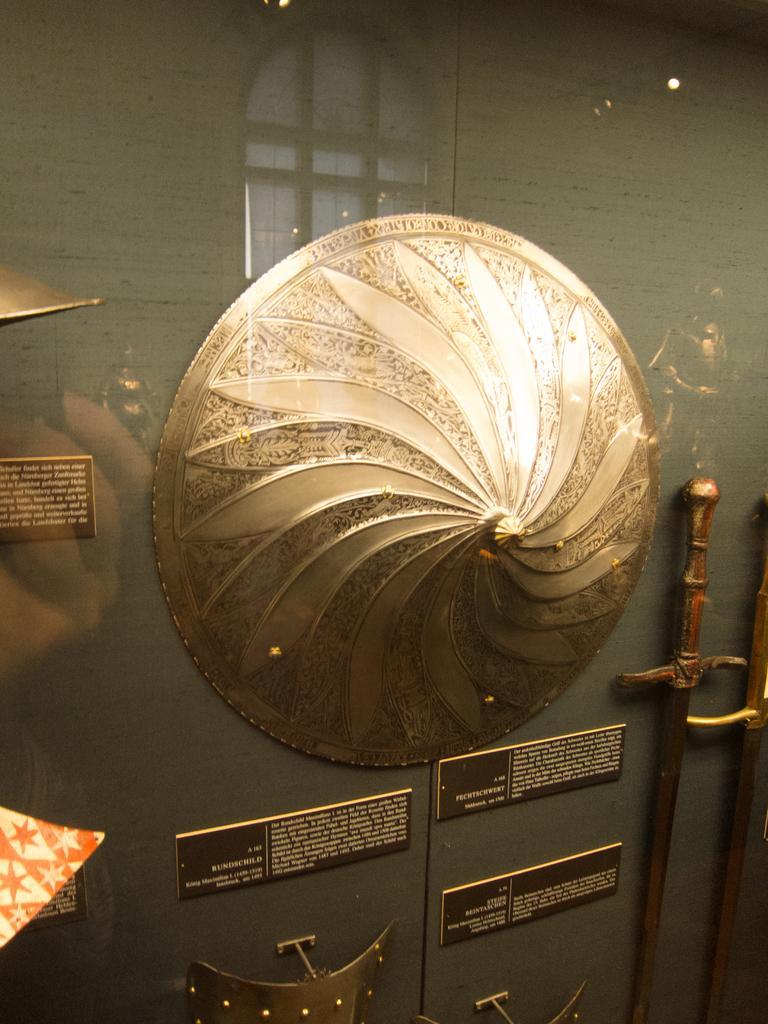Can you describe this image briefly? There is a glass wall. In the back there is a wall. On the wall there is a shield, swords and name plates with something written on that. On the glass there is a reflection of window. 